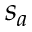<formula> <loc_0><loc_0><loc_500><loc_500>s _ { a }</formula> 